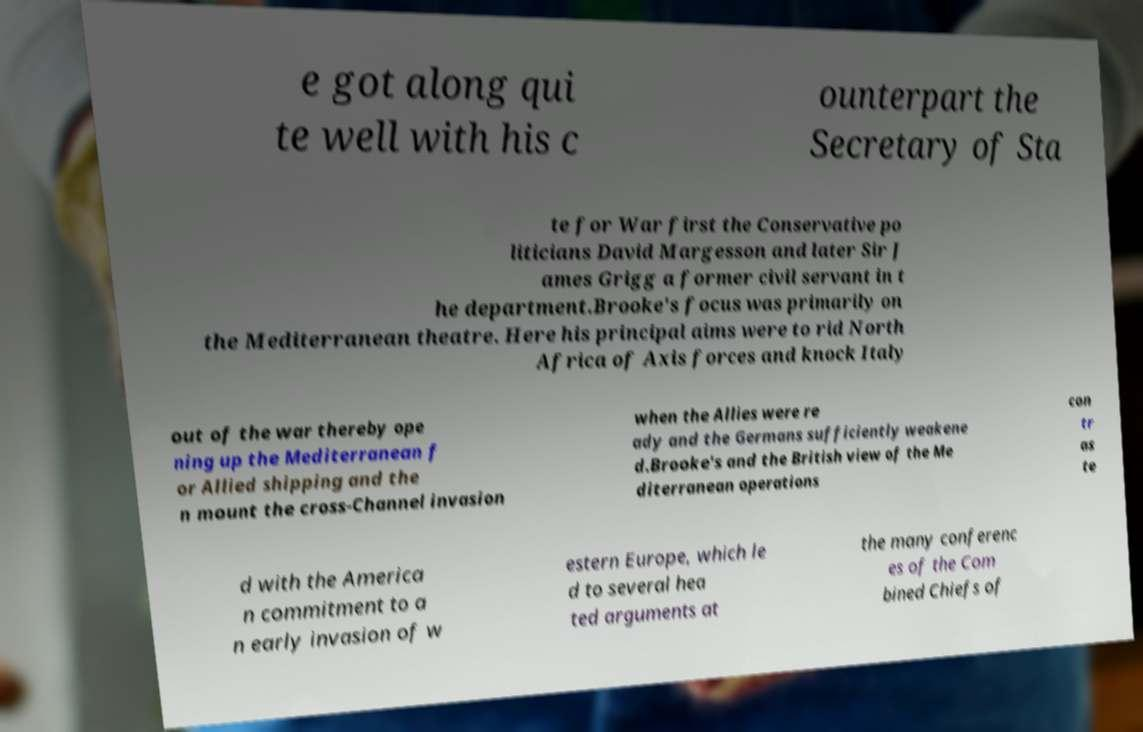For documentation purposes, I need the text within this image transcribed. Could you provide that? e got along qui te well with his c ounterpart the Secretary of Sta te for War first the Conservative po liticians David Margesson and later Sir J ames Grigg a former civil servant in t he department.Brooke's focus was primarily on the Mediterranean theatre. Here his principal aims were to rid North Africa of Axis forces and knock Italy out of the war thereby ope ning up the Mediterranean f or Allied shipping and the n mount the cross-Channel invasion when the Allies were re ady and the Germans sufficiently weakene d.Brooke's and the British view of the Me diterranean operations con tr as te d with the America n commitment to a n early invasion of w estern Europe, which le d to several hea ted arguments at the many conferenc es of the Com bined Chiefs of 